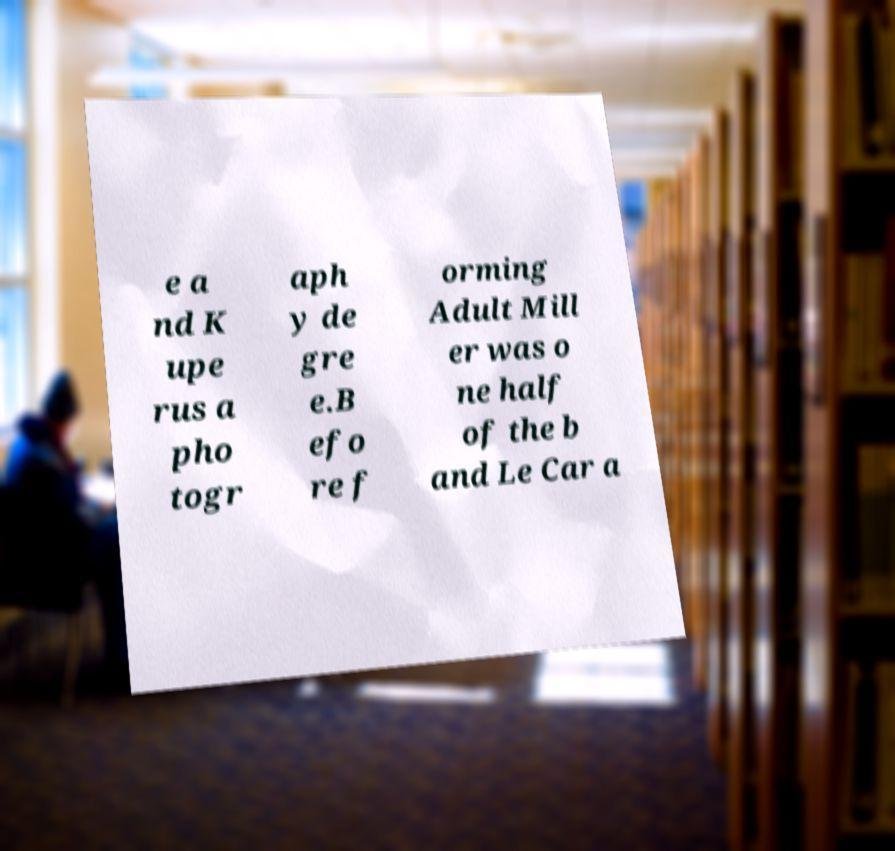Could you extract and type out the text from this image? e a nd K upe rus a pho togr aph y de gre e.B efo re f orming Adult Mill er was o ne half of the b and Le Car a 